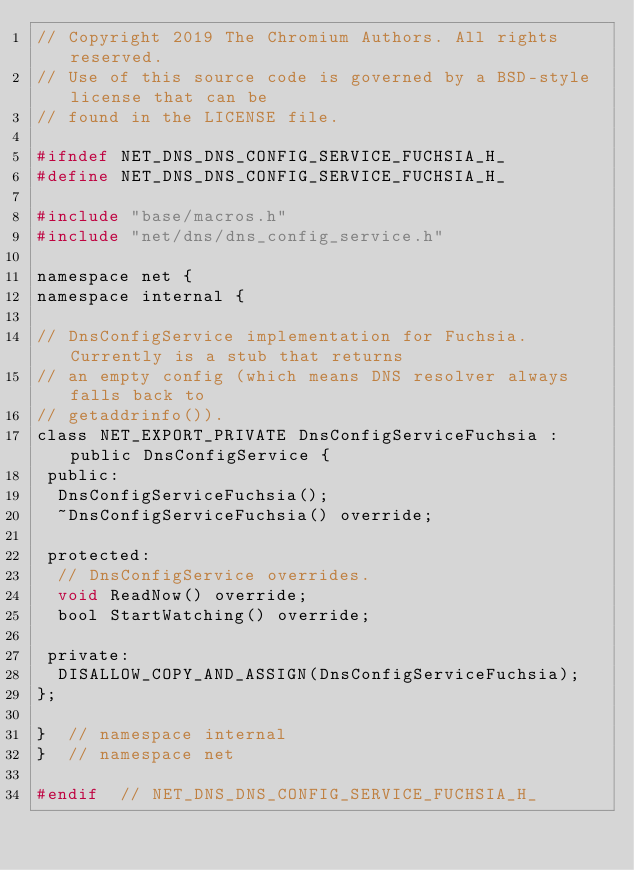<code> <loc_0><loc_0><loc_500><loc_500><_C_>// Copyright 2019 The Chromium Authors. All rights reserved.
// Use of this source code is governed by a BSD-style license that can be
// found in the LICENSE file.

#ifndef NET_DNS_DNS_CONFIG_SERVICE_FUCHSIA_H_
#define NET_DNS_DNS_CONFIG_SERVICE_FUCHSIA_H_

#include "base/macros.h"
#include "net/dns/dns_config_service.h"

namespace net {
namespace internal {

// DnsConfigService implementation for Fuchsia. Currently is a stub that returns
// an empty config (which means DNS resolver always falls back to
// getaddrinfo()).
class NET_EXPORT_PRIVATE DnsConfigServiceFuchsia : public DnsConfigService {
 public:
  DnsConfigServiceFuchsia();
  ~DnsConfigServiceFuchsia() override;

 protected:
  // DnsConfigService overrides.
  void ReadNow() override;
  bool StartWatching() override;

 private:
  DISALLOW_COPY_AND_ASSIGN(DnsConfigServiceFuchsia);
};

}  // namespace internal
}  // namespace net

#endif  // NET_DNS_DNS_CONFIG_SERVICE_FUCHSIA_H_
</code> 